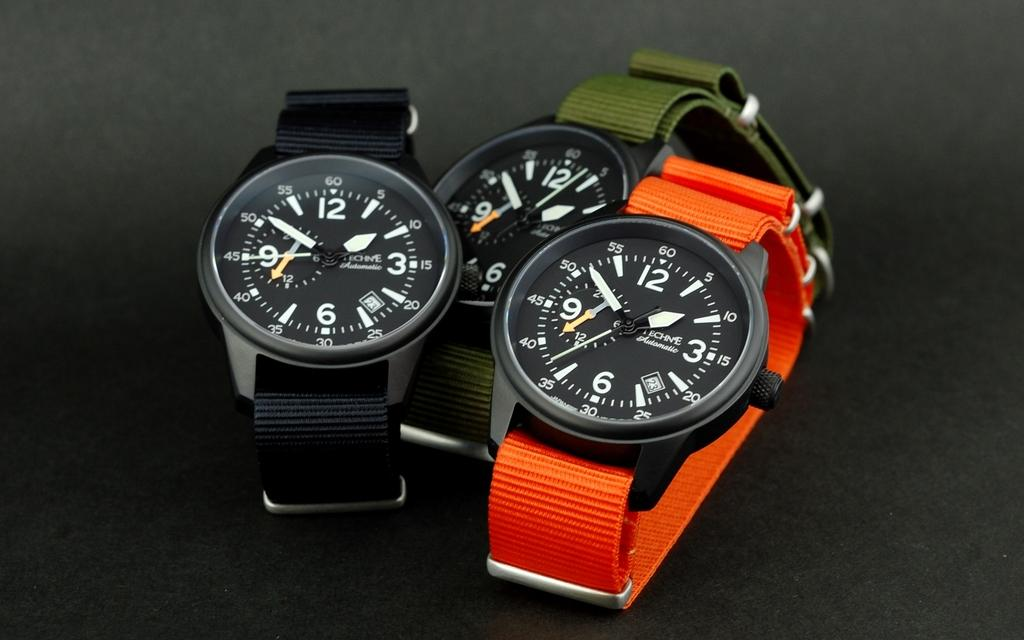<image>
Share a concise interpretation of the image provided. A watch with a green fabric band showing the current time as 1:52. 